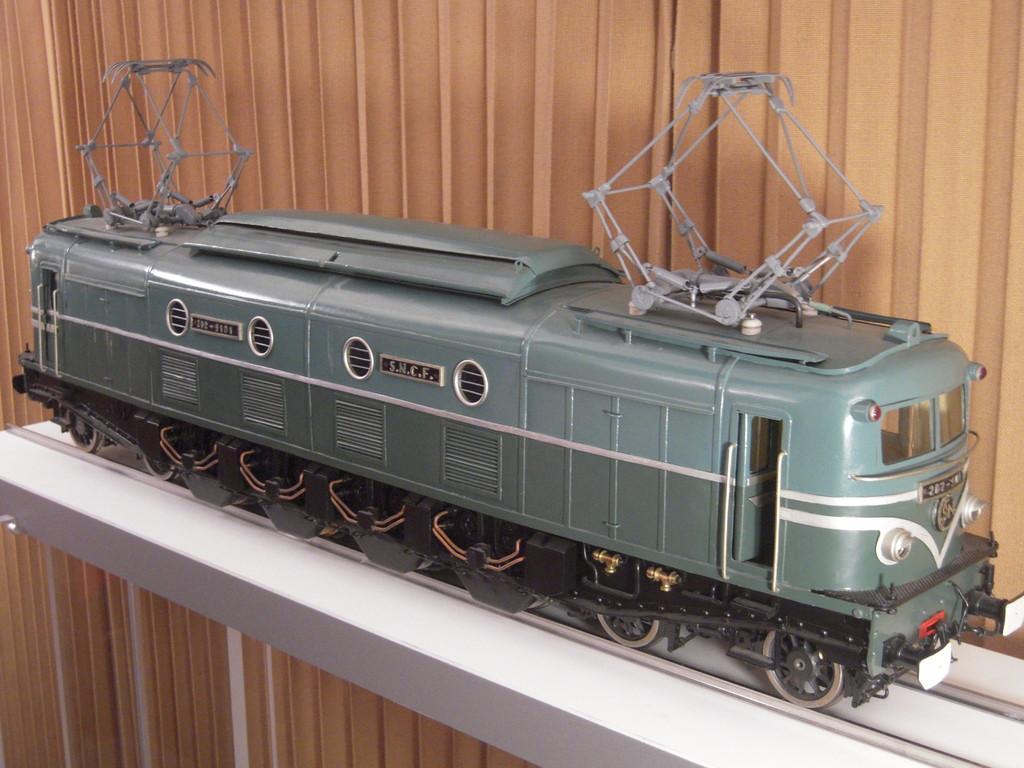What type of train is visible in the image? There is a green miniature train in the image. Where is the train located? The train is placed on a white table. What can be seen in the background of the image? There is a brown curtain in the background of the image. What is the coefficient of friction between the train and the table in the image? The image does not provide information about the coefficient of friction between the train and the table, as it is not a scientific analysis. 